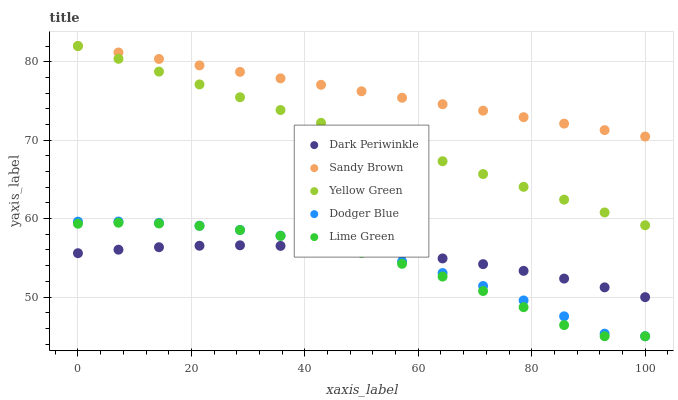Does Lime Green have the minimum area under the curve?
Answer yes or no. Yes. Does Sandy Brown have the maximum area under the curve?
Answer yes or no. Yes. Does Dark Periwinkle have the minimum area under the curve?
Answer yes or no. No. Does Dark Periwinkle have the maximum area under the curve?
Answer yes or no. No. Is Sandy Brown the smoothest?
Answer yes or no. Yes. Is Lime Green the roughest?
Answer yes or no. Yes. Is Dark Periwinkle the smoothest?
Answer yes or no. No. Is Dark Periwinkle the roughest?
Answer yes or no. No. Does Dodger Blue have the lowest value?
Answer yes or no. Yes. Does Dark Periwinkle have the lowest value?
Answer yes or no. No. Does Yellow Green have the highest value?
Answer yes or no. Yes. Does Dark Periwinkle have the highest value?
Answer yes or no. No. Is Lime Green less than Sandy Brown?
Answer yes or no. Yes. Is Yellow Green greater than Dark Periwinkle?
Answer yes or no. Yes. Does Lime Green intersect Dodger Blue?
Answer yes or no. Yes. Is Lime Green less than Dodger Blue?
Answer yes or no. No. Is Lime Green greater than Dodger Blue?
Answer yes or no. No. Does Lime Green intersect Sandy Brown?
Answer yes or no. No. 